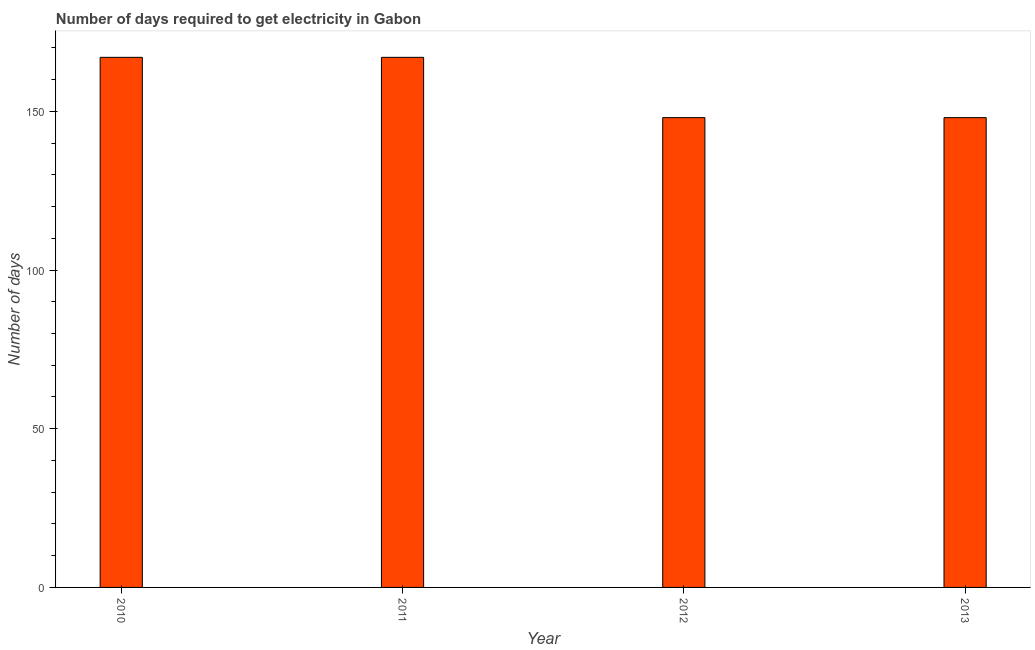Does the graph contain any zero values?
Ensure brevity in your answer.  No. Does the graph contain grids?
Your answer should be compact. No. What is the title of the graph?
Make the answer very short. Number of days required to get electricity in Gabon. What is the label or title of the Y-axis?
Provide a succinct answer. Number of days. What is the time to get electricity in 2011?
Offer a very short reply. 167. Across all years, what is the maximum time to get electricity?
Offer a very short reply. 167. Across all years, what is the minimum time to get electricity?
Make the answer very short. 148. In which year was the time to get electricity maximum?
Your answer should be compact. 2010. In which year was the time to get electricity minimum?
Ensure brevity in your answer.  2012. What is the sum of the time to get electricity?
Your answer should be very brief. 630. What is the difference between the time to get electricity in 2011 and 2013?
Give a very brief answer. 19. What is the average time to get electricity per year?
Give a very brief answer. 157. What is the median time to get electricity?
Your answer should be compact. 157.5. What is the ratio of the time to get electricity in 2011 to that in 2012?
Your response must be concise. 1.13. What is the difference between the highest and the second highest time to get electricity?
Your answer should be compact. 0. In how many years, is the time to get electricity greater than the average time to get electricity taken over all years?
Keep it short and to the point. 2. How many bars are there?
Give a very brief answer. 4. How many years are there in the graph?
Your response must be concise. 4. What is the difference between two consecutive major ticks on the Y-axis?
Your answer should be compact. 50. Are the values on the major ticks of Y-axis written in scientific E-notation?
Keep it short and to the point. No. What is the Number of days in 2010?
Offer a terse response. 167. What is the Number of days of 2011?
Your answer should be compact. 167. What is the Number of days of 2012?
Ensure brevity in your answer.  148. What is the Number of days in 2013?
Your answer should be compact. 148. What is the difference between the Number of days in 2010 and 2012?
Provide a succinct answer. 19. What is the difference between the Number of days in 2011 and 2012?
Your response must be concise. 19. What is the difference between the Number of days in 2011 and 2013?
Give a very brief answer. 19. What is the ratio of the Number of days in 2010 to that in 2012?
Provide a succinct answer. 1.13. What is the ratio of the Number of days in 2010 to that in 2013?
Give a very brief answer. 1.13. What is the ratio of the Number of days in 2011 to that in 2012?
Your answer should be very brief. 1.13. What is the ratio of the Number of days in 2011 to that in 2013?
Provide a short and direct response. 1.13. What is the ratio of the Number of days in 2012 to that in 2013?
Give a very brief answer. 1. 